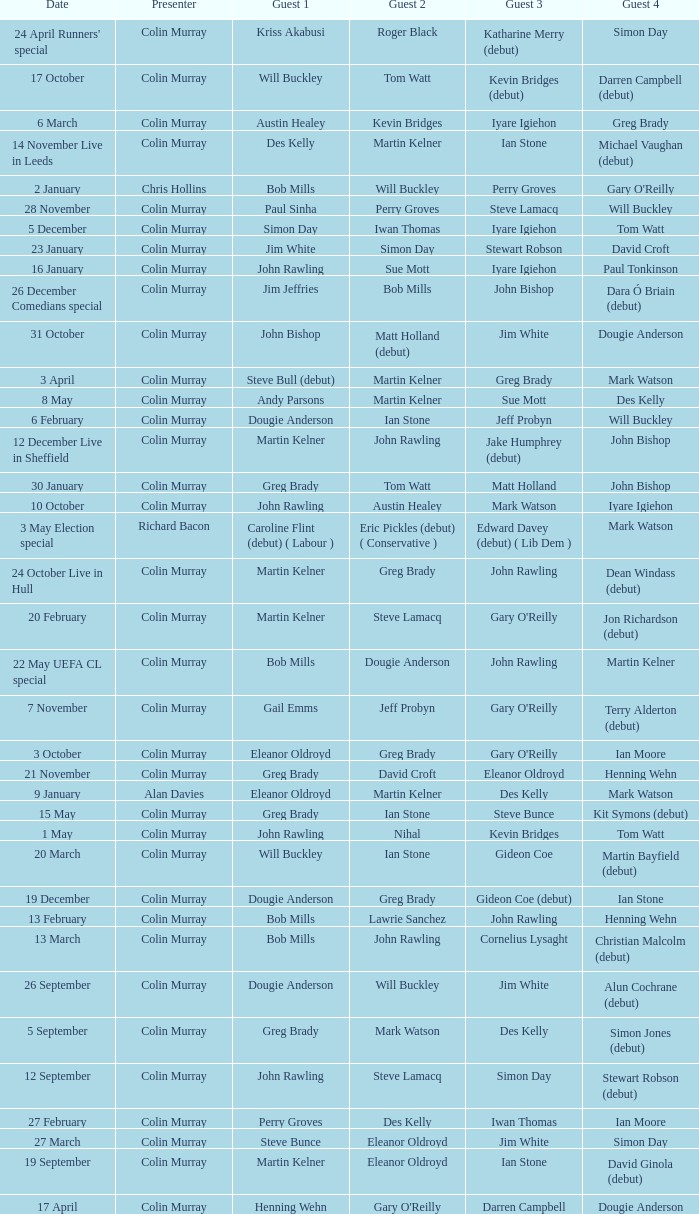On episodes where guest 1 is Jim White, who was guest 3? Stewart Robson. 